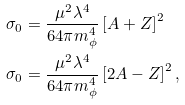<formula> <loc_0><loc_0><loc_500><loc_500>\sigma _ { 0 } & = \frac { \mu ^ { 2 } \lambda ^ { 4 } } { 6 4 \pi m _ { \phi } ^ { 4 } } \left [ A + Z \right ] ^ { 2 } \\ \sigma _ { 0 } & = \frac { \mu ^ { 2 } \lambda ^ { 4 } } { 6 4 \pi m _ { \phi } ^ { 4 } } \left [ 2 A - Z \right ] ^ { 2 } ,</formula> 